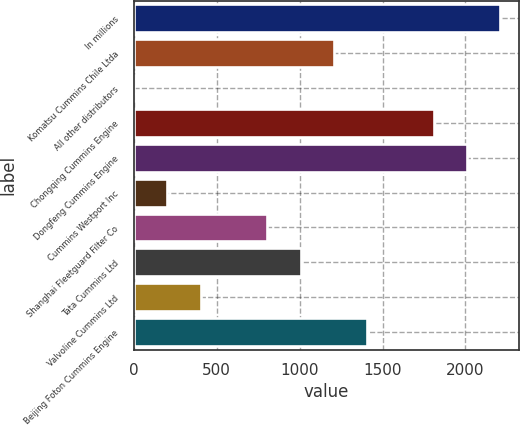Convert chart. <chart><loc_0><loc_0><loc_500><loc_500><bar_chart><fcel>In millions<fcel>Komatsu Cummins Chile Ltda<fcel>All other distributors<fcel>Chongqing Cummins Engine<fcel>Dongfeng Cummins Engine<fcel>Cummins Westport Inc<fcel>Shanghai Fleetguard Filter Co<fcel>Tata Cummins Ltd<fcel>Valvoline Cummins Ltd<fcel>Beijing Foton Cummins Engine<nl><fcel>2210.9<fcel>1206.4<fcel>1<fcel>1809.1<fcel>2010<fcel>201.9<fcel>804.6<fcel>1005.5<fcel>402.8<fcel>1407.3<nl></chart> 